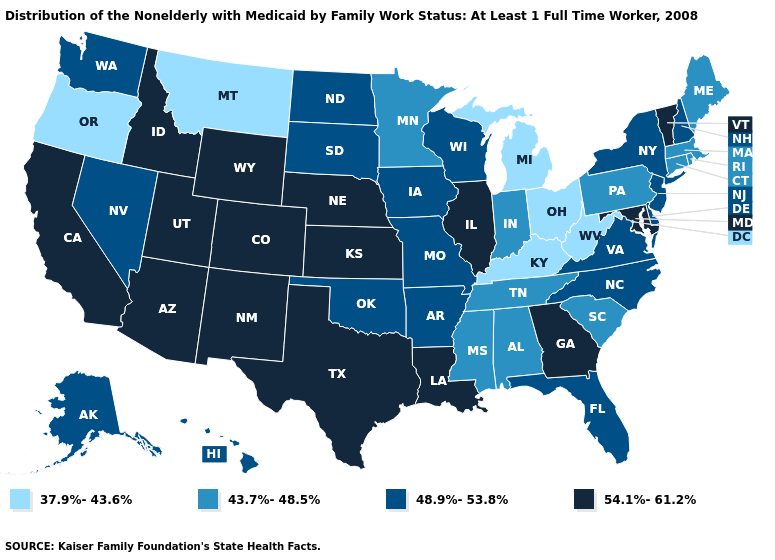What is the value of Nebraska?
Keep it brief. 54.1%-61.2%. Does the map have missing data?
Concise answer only. No. What is the highest value in the West ?
Be succinct. 54.1%-61.2%. What is the lowest value in the South?
Quick response, please. 37.9%-43.6%. Name the states that have a value in the range 54.1%-61.2%?
Answer briefly. Arizona, California, Colorado, Georgia, Idaho, Illinois, Kansas, Louisiana, Maryland, Nebraska, New Mexico, Texas, Utah, Vermont, Wyoming. What is the value of Kentucky?
Answer briefly. 37.9%-43.6%. Among the states that border Pennsylvania , does Delaware have the highest value?
Write a very short answer. No. What is the highest value in states that border Arkansas?
Concise answer only. 54.1%-61.2%. Among the states that border California , which have the lowest value?
Write a very short answer. Oregon. Does Ohio have the highest value in the MidWest?
Write a very short answer. No. Name the states that have a value in the range 54.1%-61.2%?
Write a very short answer. Arizona, California, Colorado, Georgia, Idaho, Illinois, Kansas, Louisiana, Maryland, Nebraska, New Mexico, Texas, Utah, Vermont, Wyoming. What is the value of South Carolina?
Be succinct. 43.7%-48.5%. How many symbols are there in the legend?
Concise answer only. 4. Does the first symbol in the legend represent the smallest category?
Answer briefly. Yes. Name the states that have a value in the range 43.7%-48.5%?
Give a very brief answer. Alabama, Connecticut, Indiana, Maine, Massachusetts, Minnesota, Mississippi, Pennsylvania, Rhode Island, South Carolina, Tennessee. 